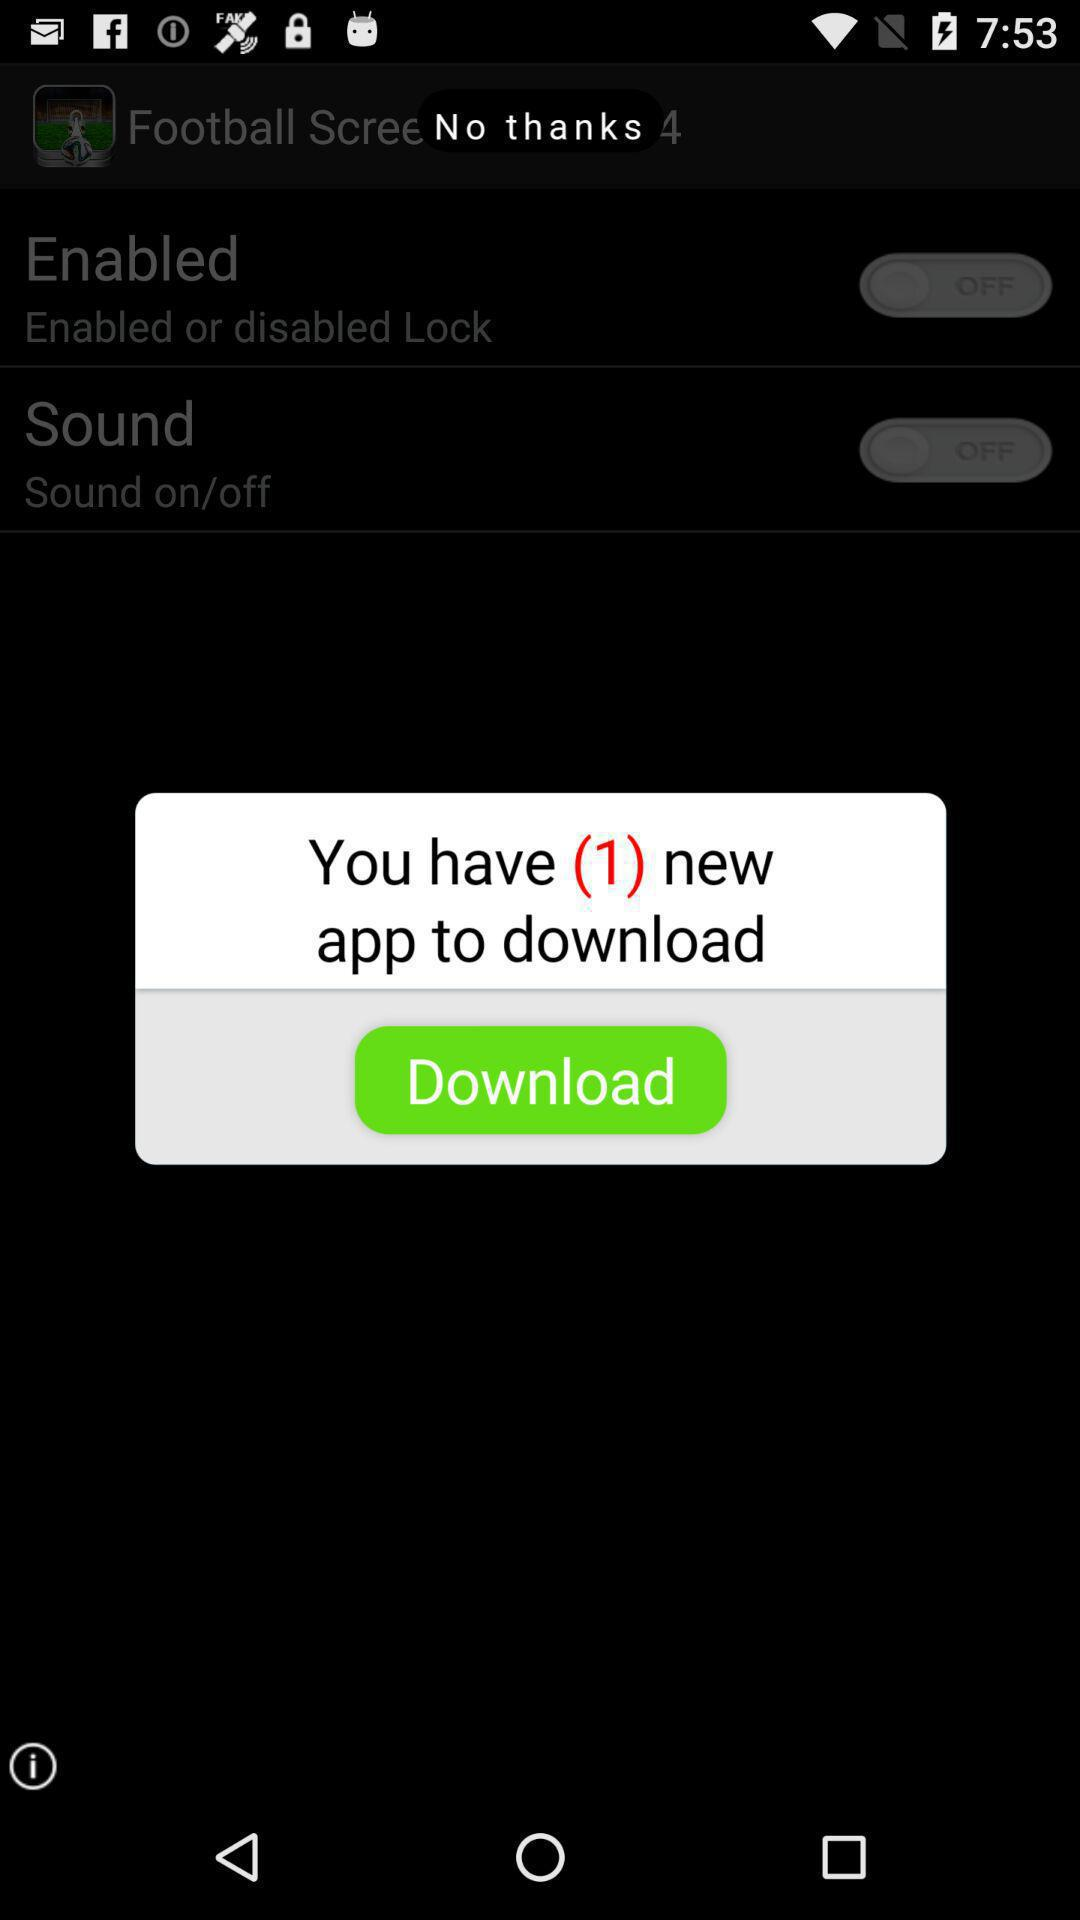How many new applications are there to download? There is 1 new application to download. 